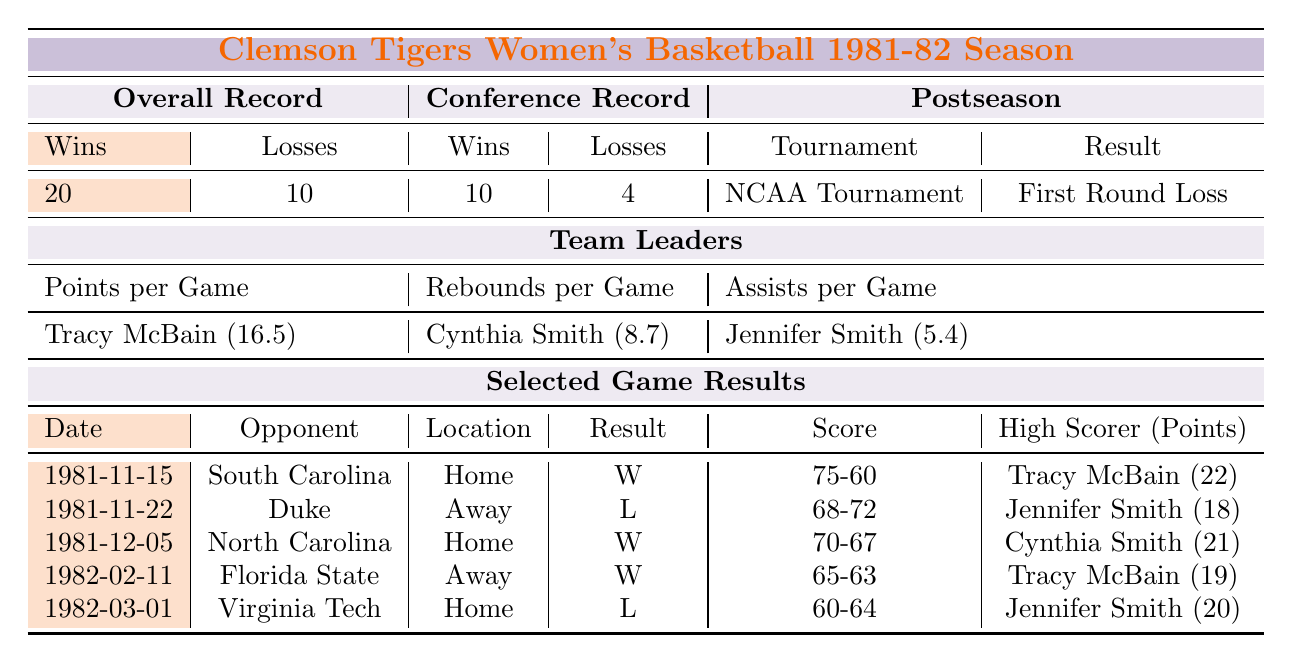How many total games did the Clemson Tigers women's basketball team play in the 1981-82 season? The overall record shows 20 wins and 10 losses. To find the total games played, add these two numbers: 20 + 10 = 30.
Answer: 30 Who was the leading scorer for the team in points per game? The team leaders section specifies that Tracy McBain averaged 16.5 points per game, making her the leading scorer.
Answer: Tracy McBain What was the team's conference win-loss record? The conference record shows 10 wins and 4 losses, which indicates the team's performance in its conference games.
Answer: 10-4 Did the Clemson Tigers women's basketball team win their game against Duke University? The result for the game against Duke University on 1981-11-22 is listed as a loss (L). Therefore, they did not win that game.
Answer: No Which player had the highest points in a single game, and how many points did she score? By looking at the selected game results, Tracy McBain scored 22 points against South Carolina on 1981-11-15, which is the highest among the listed scores.
Answer: Tracy McBain, 22 points What was the average number of rebounds per game for the team leader in that category? The team leaders section indicates that Cynthia Smith averaged 8.7 rebounds per game, which is the relevant value for this question.
Answer: 8.7 How many more wins did the team have in the overall record compared to losses? The overall record gives 20 wins and 10 losses. Subtracting the losses from the wins: 20 - 10 = 10. Thus, the team had 10 more wins than losses.
Answer: 10 What was the outcome of the NCAA Tournament for the Clemson Tigers? The postseason section shows that in the NCAA Tournament, their result was a loss (L) against the University of Maryland, with a score of 54-80.
Answer: Loss Which game did the team score 70 points? The game result shows that against the University of North Carolina on 1981-12-05, the team scored 70 points (70-67, winning the game).
Answer: University of North Carolina If Tracy McBain scored 22 points in her best game, what was her average score per game overall? Tracy McBain had an average of 16.5 points per game in overall performance. The single game points are not needed for calculating the average.
Answer: 16.5 